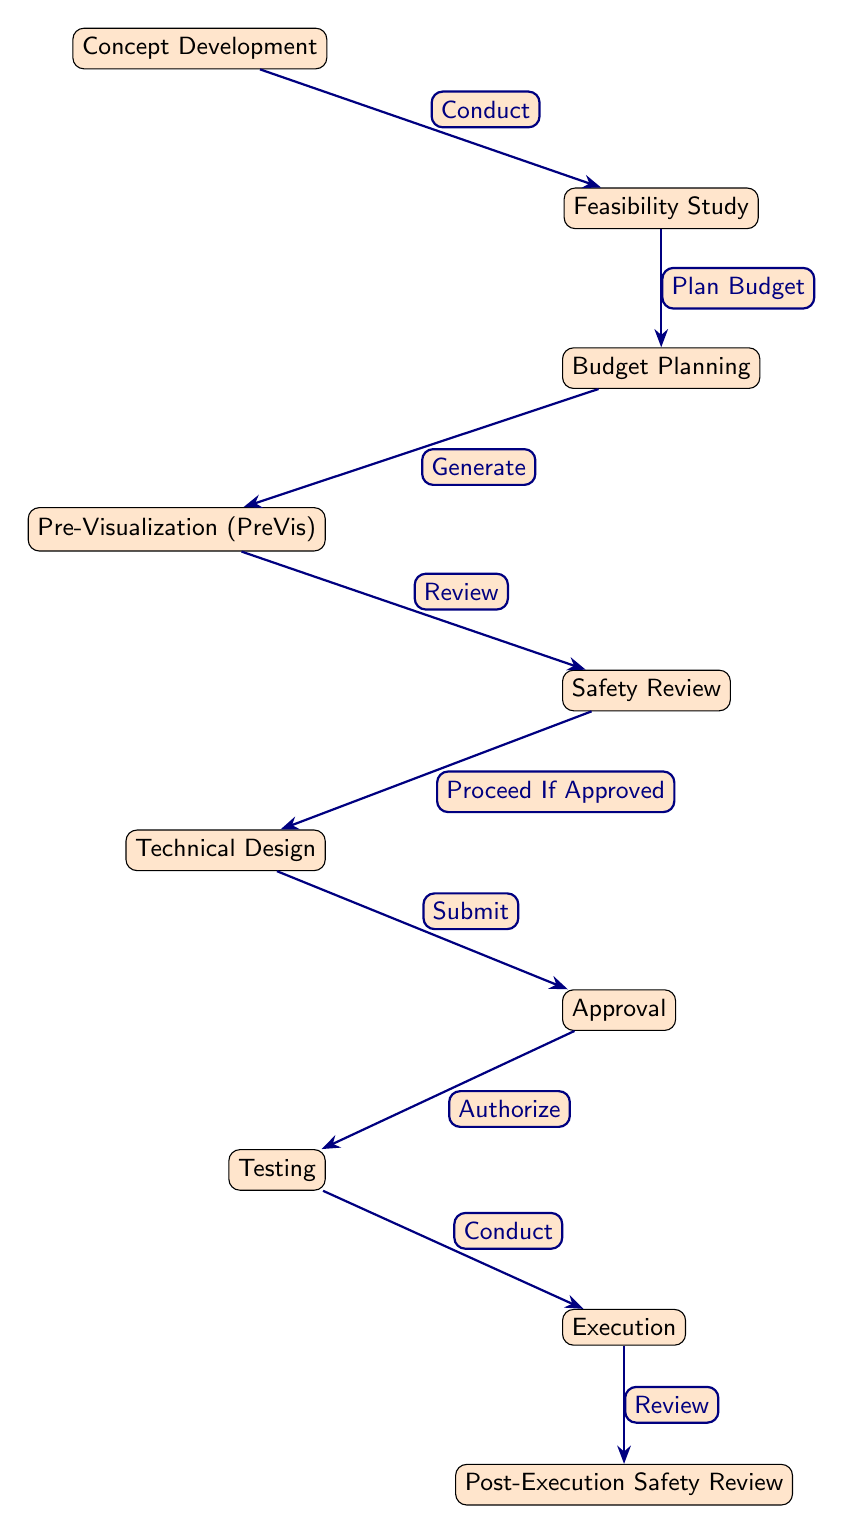What is the starting point of the workflow? The diagram shows that the workflow begins with the "Concept Development" node, indicating that this is the starting point of the special effects process.
Answer: Concept Development How many nodes are there in total? Counting all the nodes in the diagram, there are ten distinct steps in the workflow that correspond to specific stages in the special effects process.
Answer: 10 What type of review occurs after testing? The diagram indicates that after the "Testing" stage, a "Post-Execution Safety Review" is conducted to ensure safety after execution.
Answer: Post-Execution Safety Review What follows after the "Approval" stage? According to the flow in the diagram, after the "Approval" stage, the next step is "Testing", which involves checking the effects before execution.
Answer: Testing What is the relationship between "Safety Review" and "Technical Design"? The diagram shows a directional edge from "Safety Review" to "Technical Design", meaning that the design will proceed only if the safety review is approved.
Answer: Proceed If Approved How is the "Budget Planning" stage initiated? The arrow from "Feasibility Study" to "Budget Planning" signifies that the budget planning is initiated after completing the feasibility study, indicating a sequential process.
Answer: Plan Budget What happens between "Pre-Visualization" and "Safety Review"? The diagram shows that "Pre-Visualization" leads into "Safety Review" through a review process, meaning that pre-visualized effects are subject to safety assessment.
Answer: Review Which node represents the final safety check? The final safety check is represented by the "Post-Execution Safety Review" node, ensuring that all safety standards were met after the effects were executed.
Answer: Post-Execution Safety Review What action is taken after the "Concept Development"? The diagram identifies that the action taken after "Concept Development" is to conduct a "Feasibility Study", creating a necessary evaluation stage.
Answer: Conduct What is the relationship between "Technical Design" and "Approval"? According to the flowchart, "Technical Design" leads to "Approval", which implies that the design must be submitted for authorization before proceeding.
Answer: Submit 